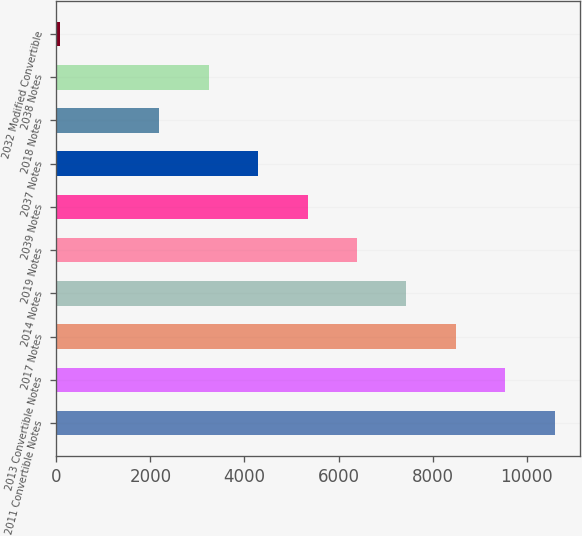Convert chart. <chart><loc_0><loc_0><loc_500><loc_500><bar_chart><fcel>2011 Convertible Notes<fcel>2013 Convertible Notes<fcel>2017 Notes<fcel>2014 Notes<fcel>2019 Notes<fcel>2039 Notes<fcel>2037 Notes<fcel>2018 Notes<fcel>2038 Notes<fcel>2032 Modified Convertible<nl><fcel>10601<fcel>9549.1<fcel>8497.2<fcel>7445.3<fcel>6393.4<fcel>5341.5<fcel>4289.6<fcel>2185.8<fcel>3237.7<fcel>82<nl></chart> 